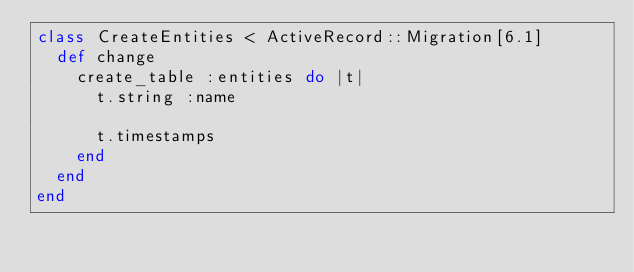Convert code to text. <code><loc_0><loc_0><loc_500><loc_500><_Ruby_>class CreateEntities < ActiveRecord::Migration[6.1]
  def change
    create_table :entities do |t|
      t.string :name

      t.timestamps
    end
  end
end
</code> 